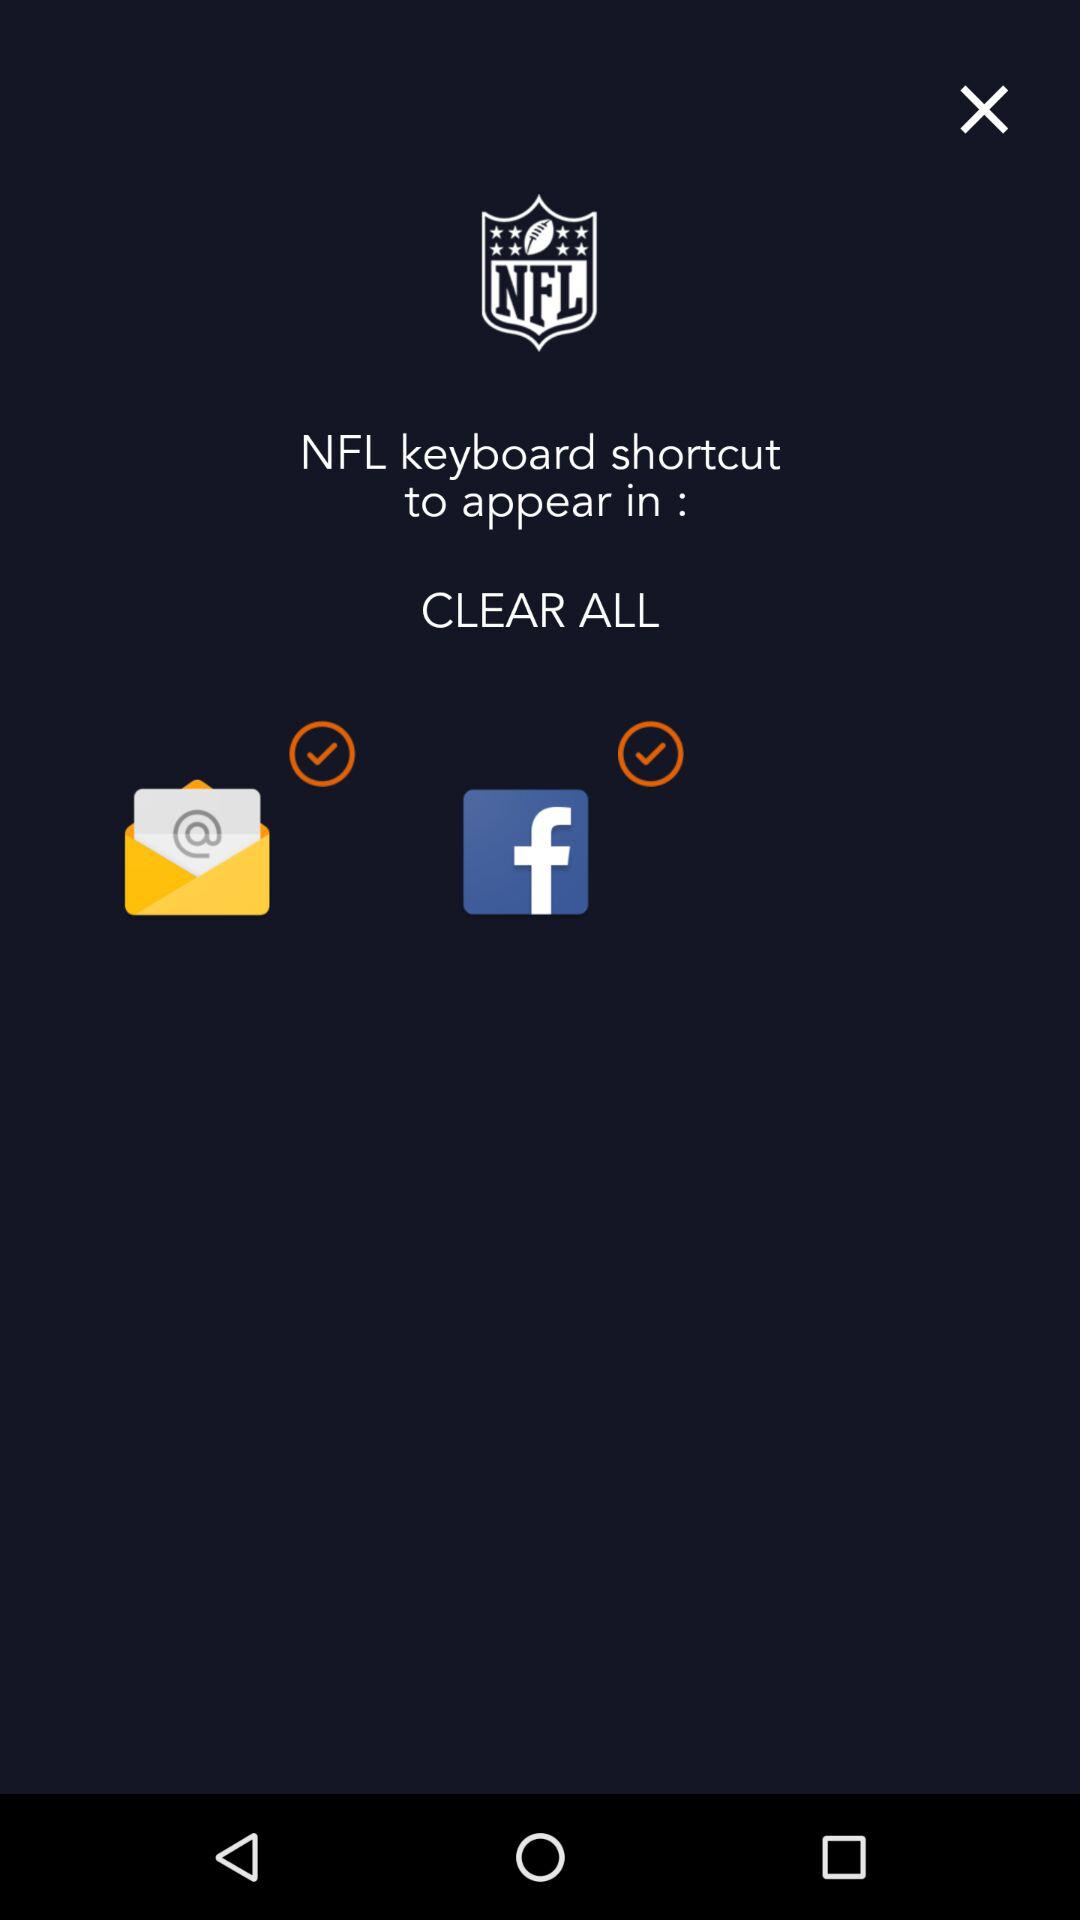What are the selected applications where the "NFL" keyboard shortcut appears? The selected applications are "Email" and "Facebook". 